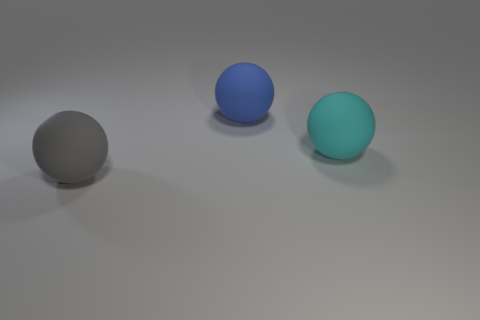Add 2 gray spheres. How many objects exist? 5 Subtract all large spheres. Subtract all large brown rubber cylinders. How many objects are left? 0 Add 2 blue balls. How many blue balls are left? 3 Add 3 balls. How many balls exist? 6 Subtract 0 green cylinders. How many objects are left? 3 